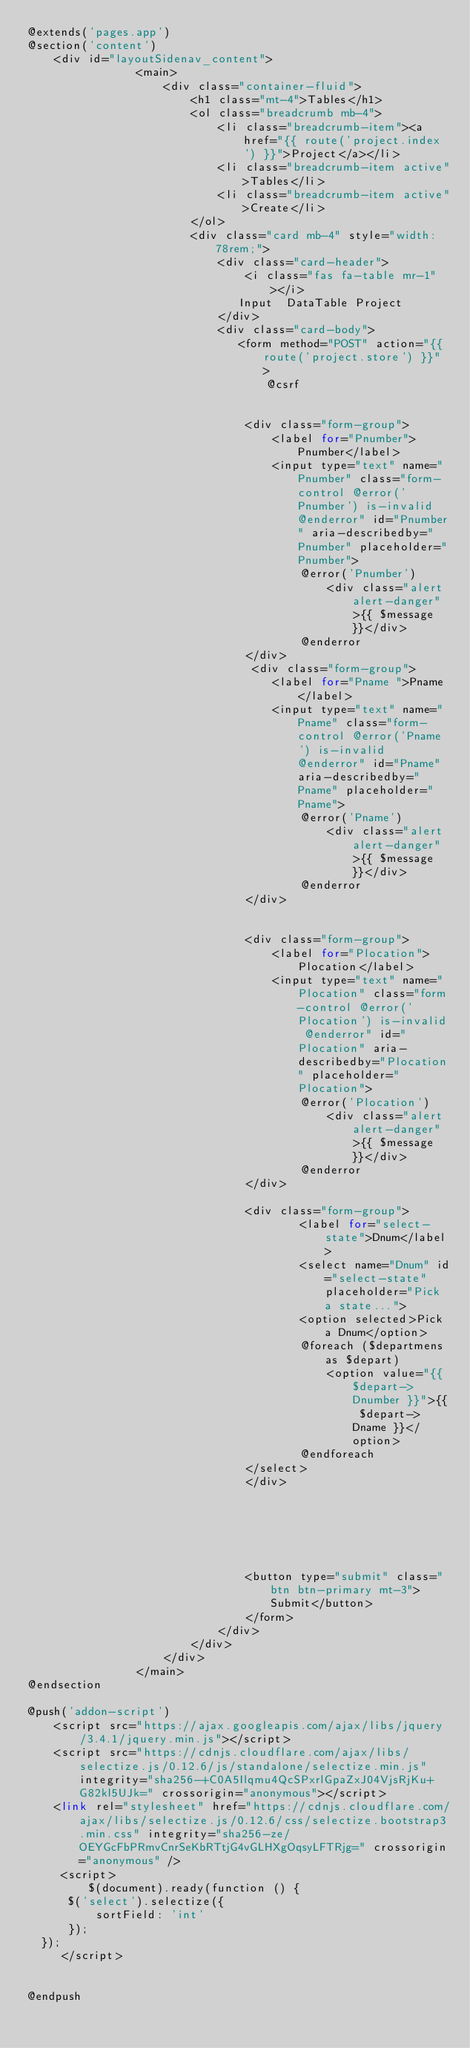Convert code to text. <code><loc_0><loc_0><loc_500><loc_500><_PHP_>@extends('pages.app')
@section('content')
    <div id="layoutSidenav_content">
                <main>
                    <div class="container-fluid">
                        <h1 class="mt-4">Tables</h1>
                        <ol class="breadcrumb mb-4">
                            <li class="breadcrumb-item"><a href="{{ route('project.index') }}">Project</a></li>
                            <li class="breadcrumb-item active">Tables</li>
                            <li class="breadcrumb-item active">Create</li>
                        </ol>
                        <div class="card mb-4" style="width: 78rem;">
                            <div class="card-header">
                                <i class="fas fa-table mr-1"></i>
                               Input  DataTable Project
                            </div>
                            <div class="card-body">
                               <form method="POST" action="{{ route('project.store') }}" >
                                   @csrf


                                <div class="form-group">
                                    <label for="Pnumber">Pnumber</label>
                                    <input type="text" name="Pnumber" class="form-control @error('Pnumber') is-invalid @enderror" id="Pnumber" aria-describedby="Pnumber" placeholder="Pnumber">
                                        @error('Pnumber')
                                            <div class="alert alert-danger">{{ $message }}</div>
                                        @enderror
                                </div>
                                 <div class="form-group">
                                    <label for="Pname ">Pname</label>
                                    <input type="text" name="Pname" class="form-control @error('Pname') is-invalid @enderror" id="Pname" aria-describedby="Pname" placeholder="Pname">
                                        @error('Pname')
                                            <div class="alert alert-danger">{{ $message }}</div>
                                        @enderror
                                </div>


                                <div class="form-group">
                                    <label for="Plocation">Plocation</label>
                                    <input type="text" name="Plocation" class="form-control @error('Plocation') is-invalid @enderror" id="Plocation" aria-describedby="Plocation" placeholder="Plocation">
                                        @error('Plocation')
                                            <div class="alert alert-danger">{{ $message }}</div>
                                        @enderror
                                </div>

                                <div class="form-group">
                                        <label for="select-state">Dnum</label>
                                        <select name="Dnum" id="select-state" placeholder="Pick a state...">
                                        <option selected>Pick a Dnum</option>
                                        @foreach ($departmens as $depart)
                                            <option value="{{ $depart->Dnumber }}">{{ $depart->Dname }}</option>
                                        @endforeach
                                </select>
                                </div>






                                <button type="submit" class="btn btn-primary mt-3">Submit</button>
                                </form>
                            </div>
                        </div>
                    </div>
                </main>
@endsection

@push('addon-script')
    <script src="https://ajax.googleapis.com/ajax/libs/jquery/3.4.1/jquery.min.js"></script>
    <script src="https://cdnjs.cloudflare.com/ajax/libs/selectize.js/0.12.6/js/standalone/selectize.min.js" integrity="sha256-+C0A5Ilqmu4QcSPxrlGpaZxJ04VjsRjKu+G82kl5UJk=" crossorigin="anonymous"></script>
    <link rel="stylesheet" href="https://cdnjs.cloudflare.com/ajax/libs/selectize.js/0.12.6/css/selectize.bootstrap3.min.css" integrity="sha256-ze/OEYGcFbPRmvCnrSeKbRTtjG4vGLHXgOqsyLFTRjg=" crossorigin="anonymous" />
     <script>
         $(document).ready(function () {
      $('select').selectize({
          sortField: 'int'
      });
  });
     </script>


@endpush




</code> 